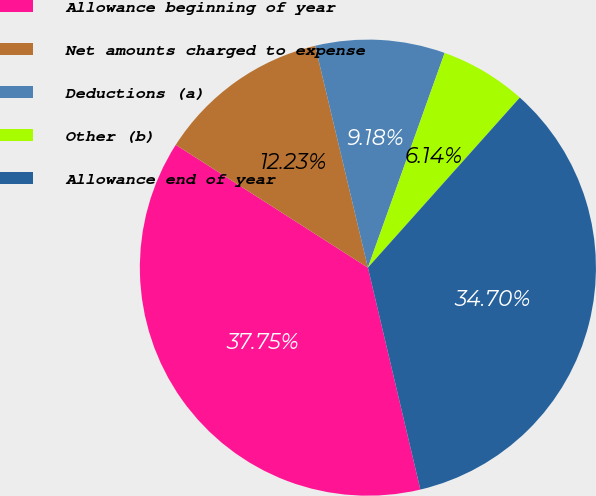Convert chart. <chart><loc_0><loc_0><loc_500><loc_500><pie_chart><fcel>Allowance beginning of year<fcel>Net amounts charged to expense<fcel>Deductions (a)<fcel>Other (b)<fcel>Allowance end of year<nl><fcel>37.75%<fcel>12.23%<fcel>9.18%<fcel>6.14%<fcel>34.7%<nl></chart> 